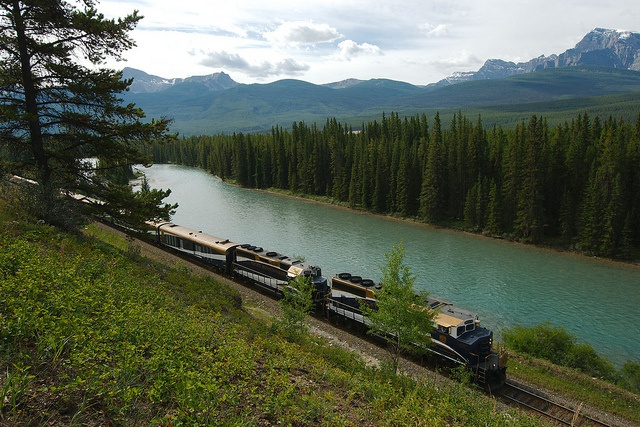Describe the objects in this image and their specific colors. I can see a train in black, gray, darkgray, and darkgreen tones in this image. 